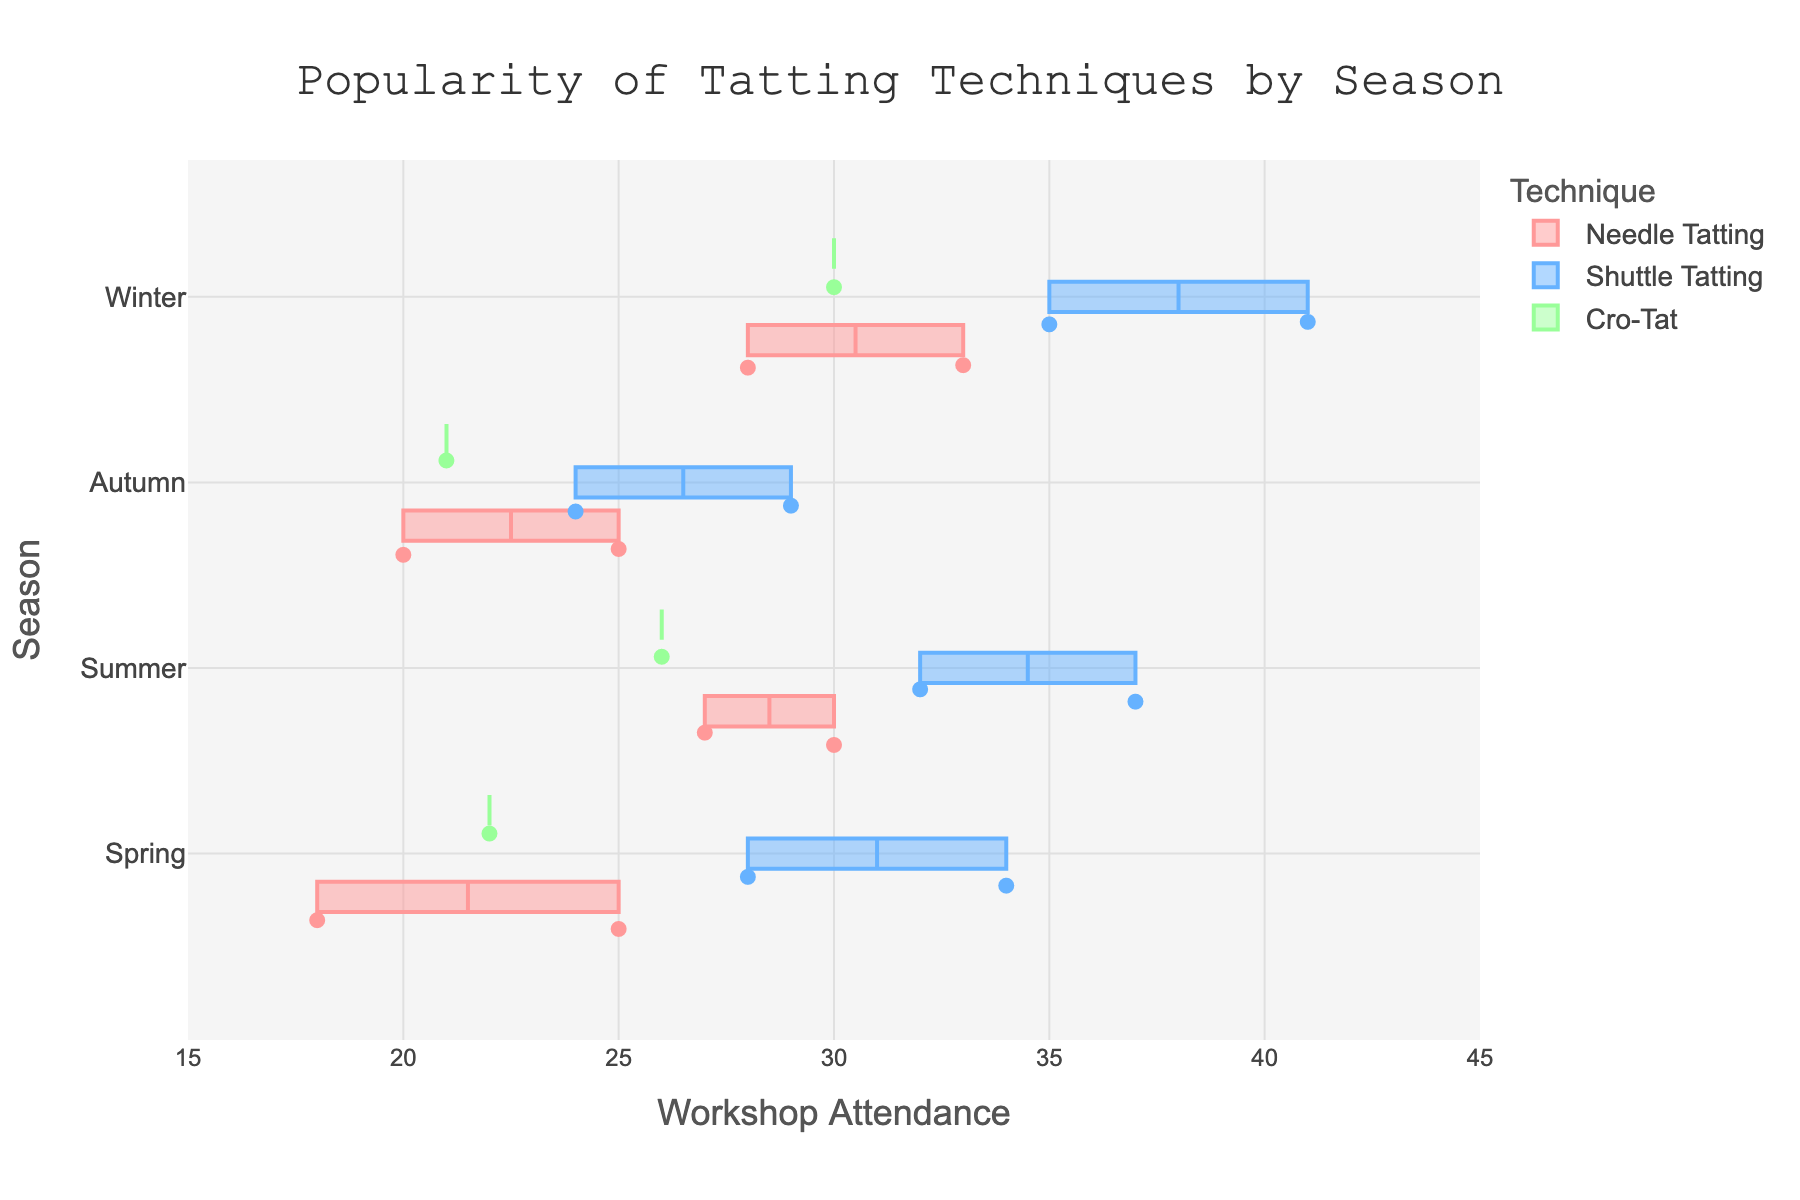What is the title of the figure? The title is usually prominently displayed at the top of the chart. In this case, it is the text that summarizes what the plot is about, which is "Popularity of Tatting Techniques by Season".
Answer: Popularity of Tatting Techniques by Season How is the attendance for Needle Tatting workshops displayed? Attendance for Needle Tatting workshops is displayed using horizontal box plots. Each box plot represents the distribution of attendance data across different seasons, with points showing individual attendance counts. The color used for Needle Tatting is a shade of pink.
Answer: Horizontal box plots in pink What season has the highest median attendance for Shuttle Tatting? To find the season with the highest median attendance for Shuttle Tatting, one should look at the middle line inside each box plot that represents the Shuttle Tatting data. The box representing winter has the highest median line.
Answer: Winter Compare the workshop attendance for Cro-Tat during Spring and Winter. Which is higher? By comparing the positions and lengths of the box plots for Cro-Tat in Spring and Winter, we see that the Winter box plot has higher values than the Spring box plot.
Answer: Winter Which tatting technique has the largest variability in attendance in Summer? The variability in attendance is shown by the length of the box plots. For Summer, Shuttle Tatting has the largest box, indicating the greatest variability.
Answer: Shuttle Tatting Consider the attendance for Shuttle Tatting in Summer. What is the range of attendance values? The range of attendance values is the difference between the maximum and minimum points in the box plot for Shuttle Tatting in Summer. The box plot for Shuttle Tatting in Summer shows attendance values ranging from 30 to 40.
Answer: 30 to 40 What is the color used to represent Cro-Tat in the plot? The colors for different techniques are constant throughout the plot, and Cro-Tat is represented by a shade of green.
Answer: Green Which season has the lowest average attendance for Needle Tatting workshops? To determine the lowest average attendance, look for the season where the box plot for Needle Tatting is positioned lower overall. The Autumn box plot of Needle Tatting is the lowest, suggesting it has the lowest average attendance.
Answer: Autumn How does the variability in attendance for Shuttle Tatting in Winter compare against other seasons? By examining the lengths of the box plots for Shuttle Tatting across all seasons, we see that the Winter box plot is one of the longest, indicating a relatively high variability compared to other seasons.
Answer: High variability What is the lowest recorded attendance for a Shuttle Tatting workshop in any season? The lowest recorded attendance for a Shuttle Tatting workshop is shown by the lowest point on the box plots for Shuttle Tatting across all seasons. The lowest point is 24 in Autumn.
Answer: 24 